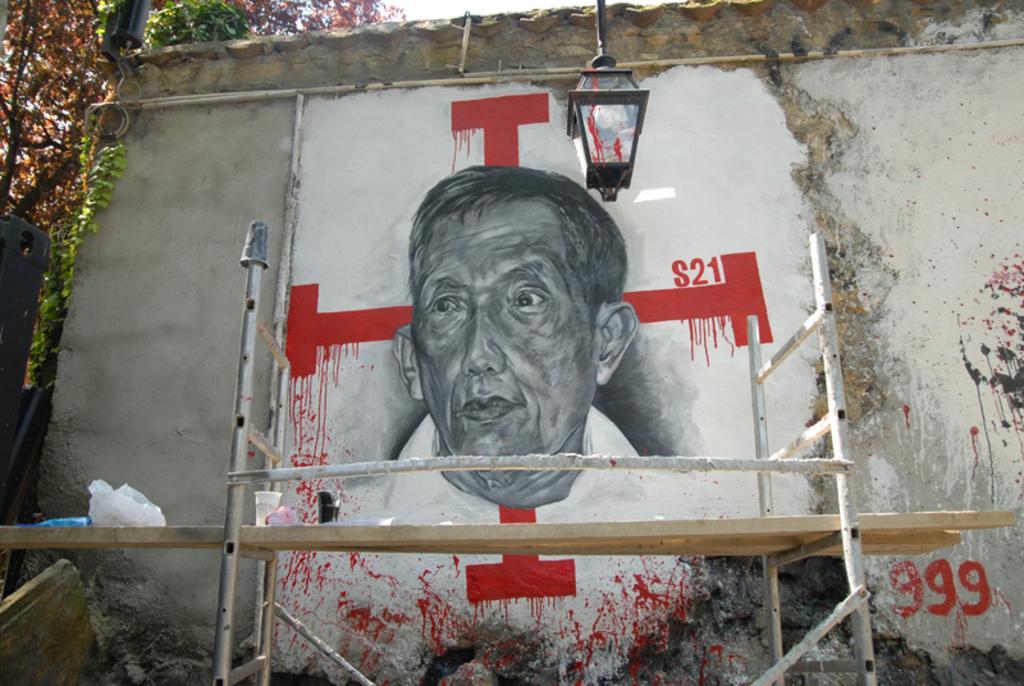Can you describe this image briefly? In this image I can see a painting of a man on a wall. At the bottom there is a wooden plank placed on two ladders. On this wooden plank there is a glass and some other objects are placed. In the top left-hand corner few leaves are visible. 